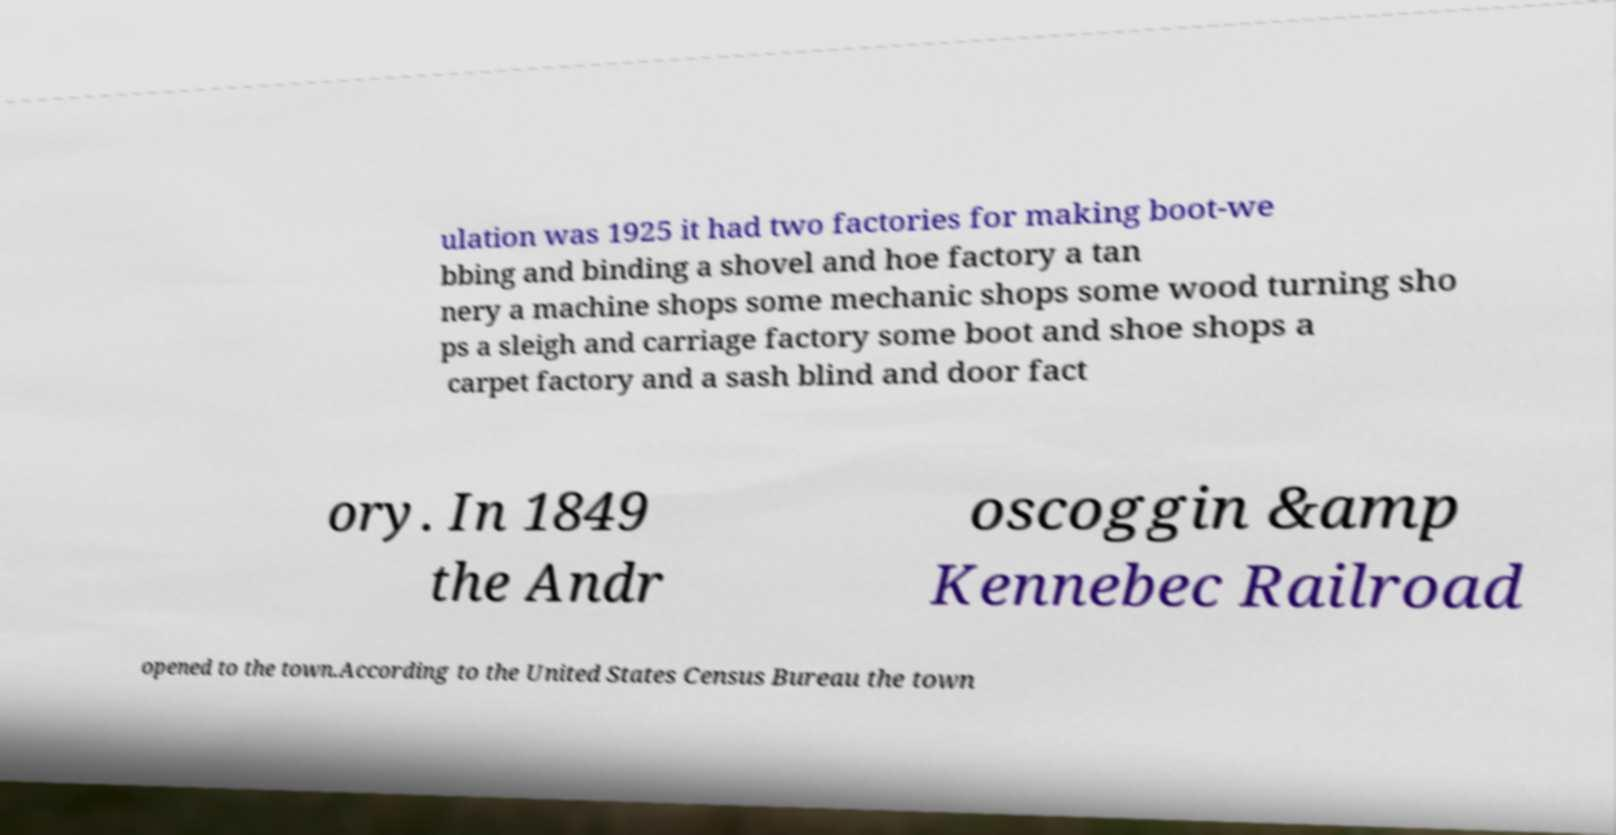What messages or text are displayed in this image? I need them in a readable, typed format. ulation was 1925 it had two factories for making boot-we bbing and binding a shovel and hoe factory a tan nery a machine shops some mechanic shops some wood turning sho ps a sleigh and carriage factory some boot and shoe shops a carpet factory and a sash blind and door fact ory. In 1849 the Andr oscoggin &amp Kennebec Railroad opened to the town.According to the United States Census Bureau the town 